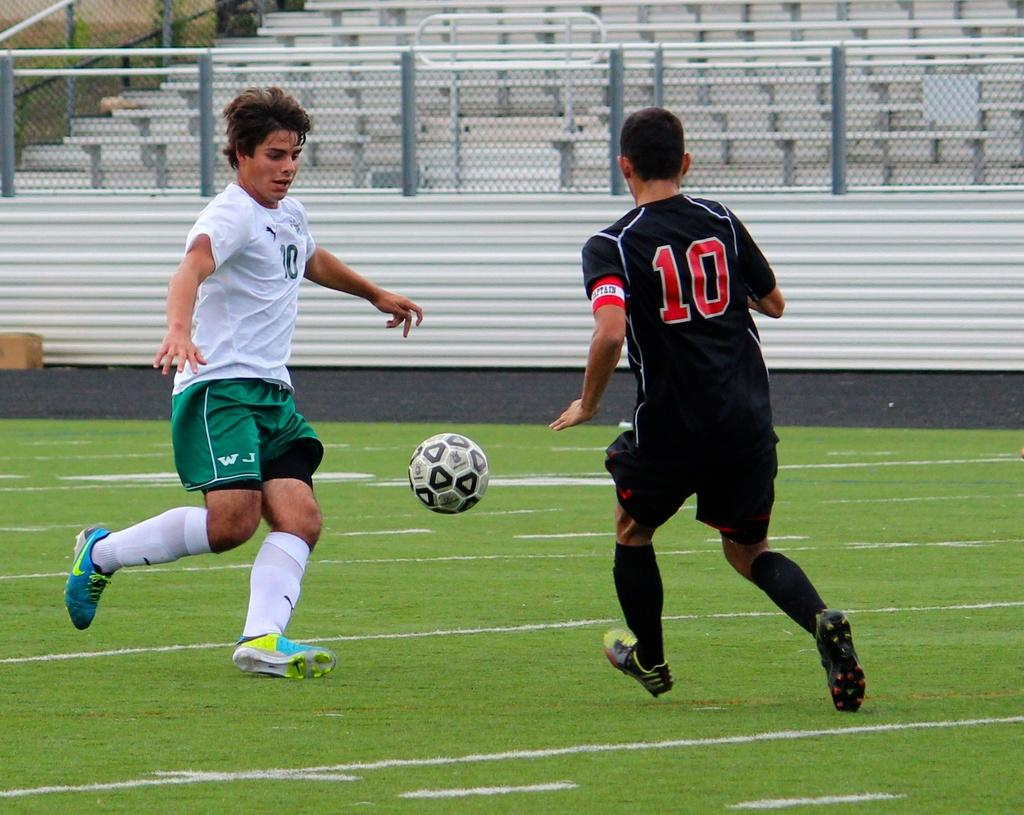<image>
Write a terse but informative summary of the picture. A person in a black number 10 jersey plays soccer with a white jersey. 